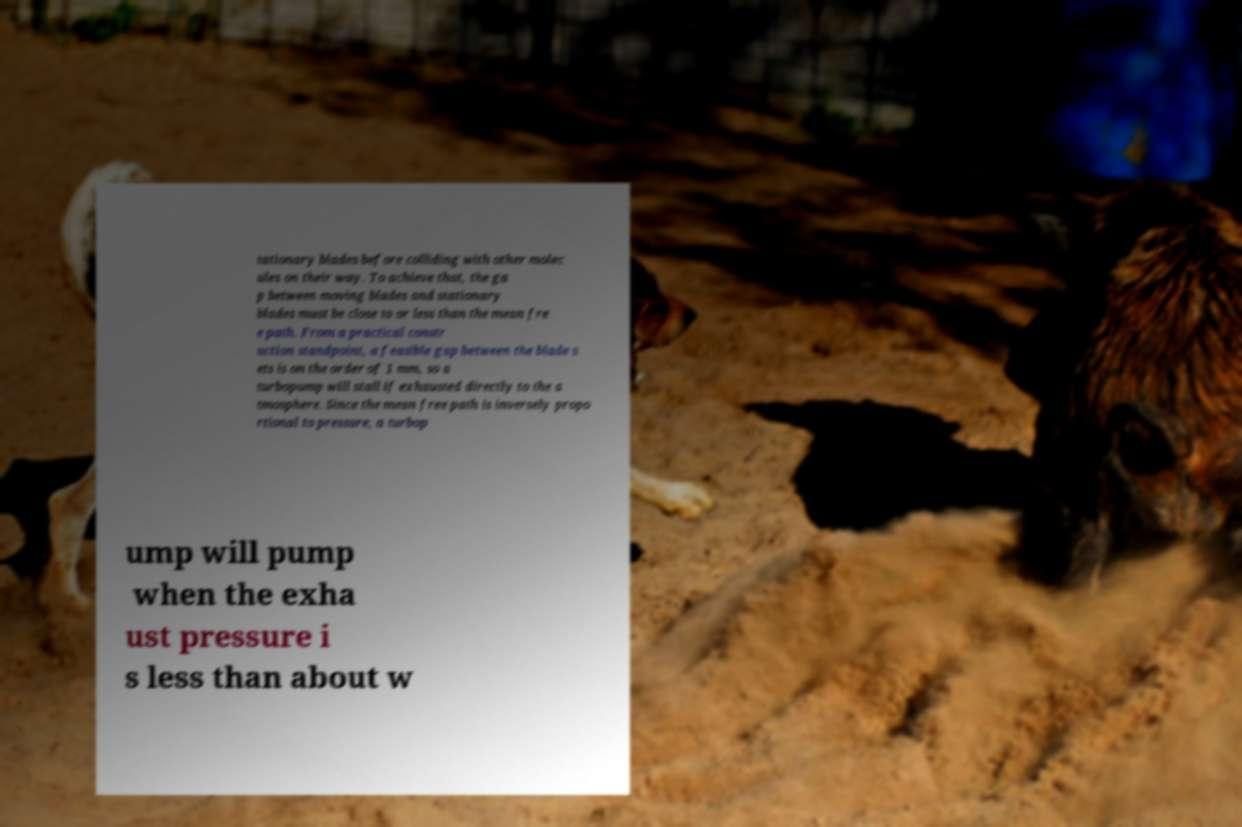Can you accurately transcribe the text from the provided image for me? tationary blades before colliding with other molec ules on their way. To achieve that, the ga p between moving blades and stationary blades must be close to or less than the mean fre e path. From a practical constr uction standpoint, a feasible gap between the blade s ets is on the order of 1 mm, so a turbopump will stall if exhausted directly to the a tmosphere. Since the mean free path is inversely propo rtional to pressure, a turbop ump will pump when the exha ust pressure i s less than about w 